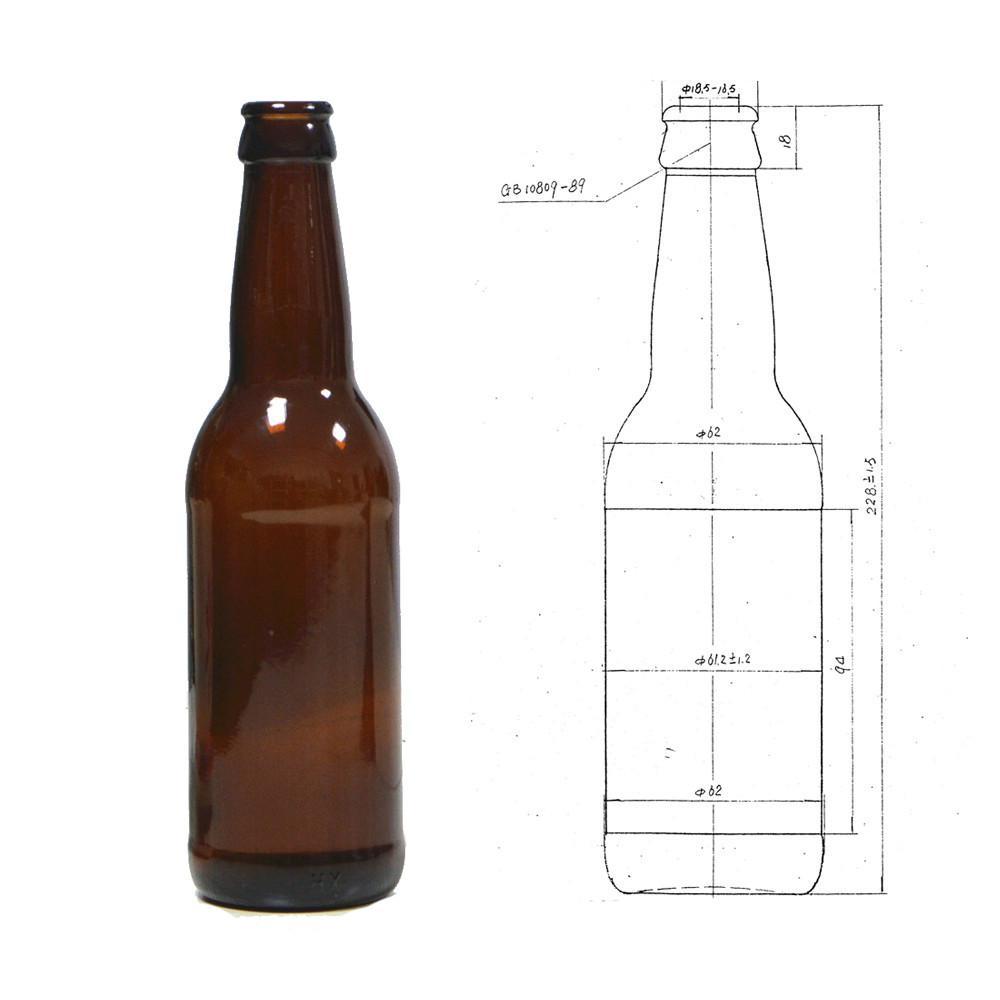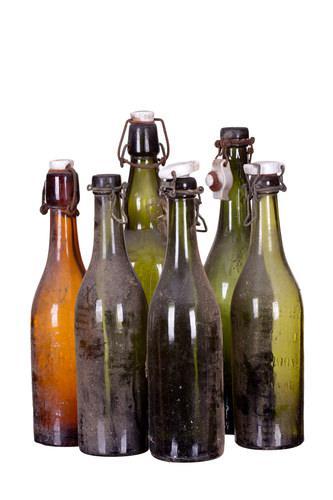The first image is the image on the left, the second image is the image on the right. Analyze the images presented: Is the assertion "More bottles are depicted in the right image than the left." valid? Answer yes or no. Yes. 